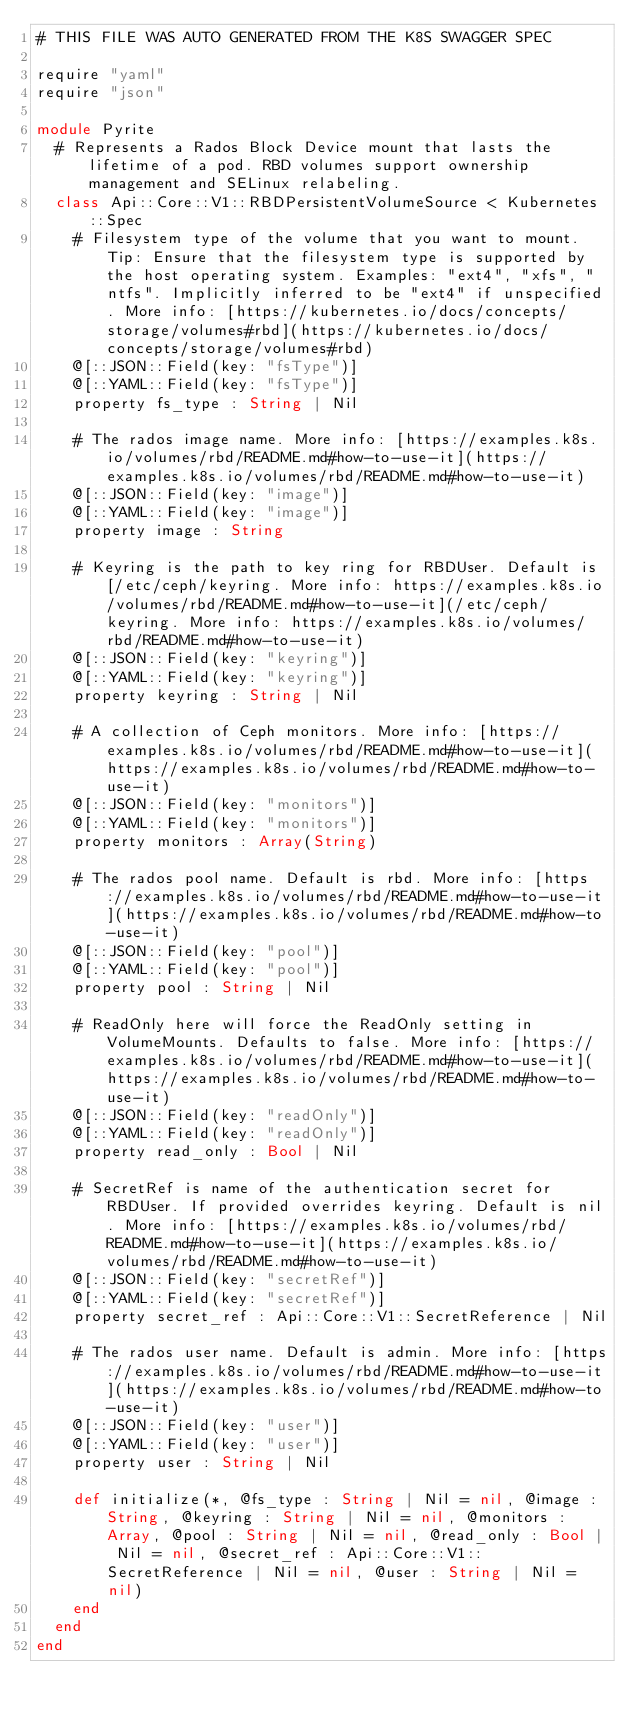Convert code to text. <code><loc_0><loc_0><loc_500><loc_500><_Crystal_># THIS FILE WAS AUTO GENERATED FROM THE K8S SWAGGER SPEC

require "yaml"
require "json"

module Pyrite
  # Represents a Rados Block Device mount that lasts the lifetime of a pod. RBD volumes support ownership management and SELinux relabeling.
  class Api::Core::V1::RBDPersistentVolumeSource < Kubernetes::Spec
    # Filesystem type of the volume that you want to mount. Tip: Ensure that the filesystem type is supported by the host operating system. Examples: "ext4", "xfs", "ntfs". Implicitly inferred to be "ext4" if unspecified. More info: [https://kubernetes.io/docs/concepts/storage/volumes#rbd](https://kubernetes.io/docs/concepts/storage/volumes#rbd)
    @[::JSON::Field(key: "fsType")]
    @[::YAML::Field(key: "fsType")]
    property fs_type : String | Nil

    # The rados image name. More info: [https://examples.k8s.io/volumes/rbd/README.md#how-to-use-it](https://examples.k8s.io/volumes/rbd/README.md#how-to-use-it)
    @[::JSON::Field(key: "image")]
    @[::YAML::Field(key: "image")]
    property image : String

    # Keyring is the path to key ring for RBDUser. Default is [/etc/ceph/keyring. More info: https://examples.k8s.io/volumes/rbd/README.md#how-to-use-it](/etc/ceph/keyring. More info: https://examples.k8s.io/volumes/rbd/README.md#how-to-use-it)
    @[::JSON::Field(key: "keyring")]
    @[::YAML::Field(key: "keyring")]
    property keyring : String | Nil

    # A collection of Ceph monitors. More info: [https://examples.k8s.io/volumes/rbd/README.md#how-to-use-it](https://examples.k8s.io/volumes/rbd/README.md#how-to-use-it)
    @[::JSON::Field(key: "monitors")]
    @[::YAML::Field(key: "monitors")]
    property monitors : Array(String)

    # The rados pool name. Default is rbd. More info: [https://examples.k8s.io/volumes/rbd/README.md#how-to-use-it](https://examples.k8s.io/volumes/rbd/README.md#how-to-use-it)
    @[::JSON::Field(key: "pool")]
    @[::YAML::Field(key: "pool")]
    property pool : String | Nil

    # ReadOnly here will force the ReadOnly setting in VolumeMounts. Defaults to false. More info: [https://examples.k8s.io/volumes/rbd/README.md#how-to-use-it](https://examples.k8s.io/volumes/rbd/README.md#how-to-use-it)
    @[::JSON::Field(key: "readOnly")]
    @[::YAML::Field(key: "readOnly")]
    property read_only : Bool | Nil

    # SecretRef is name of the authentication secret for RBDUser. If provided overrides keyring. Default is nil. More info: [https://examples.k8s.io/volumes/rbd/README.md#how-to-use-it](https://examples.k8s.io/volumes/rbd/README.md#how-to-use-it)
    @[::JSON::Field(key: "secretRef")]
    @[::YAML::Field(key: "secretRef")]
    property secret_ref : Api::Core::V1::SecretReference | Nil

    # The rados user name. Default is admin. More info: [https://examples.k8s.io/volumes/rbd/README.md#how-to-use-it](https://examples.k8s.io/volumes/rbd/README.md#how-to-use-it)
    @[::JSON::Field(key: "user")]
    @[::YAML::Field(key: "user")]
    property user : String | Nil

    def initialize(*, @fs_type : String | Nil = nil, @image : String, @keyring : String | Nil = nil, @monitors : Array, @pool : String | Nil = nil, @read_only : Bool | Nil = nil, @secret_ref : Api::Core::V1::SecretReference | Nil = nil, @user : String | Nil = nil)
    end
  end
end
</code> 